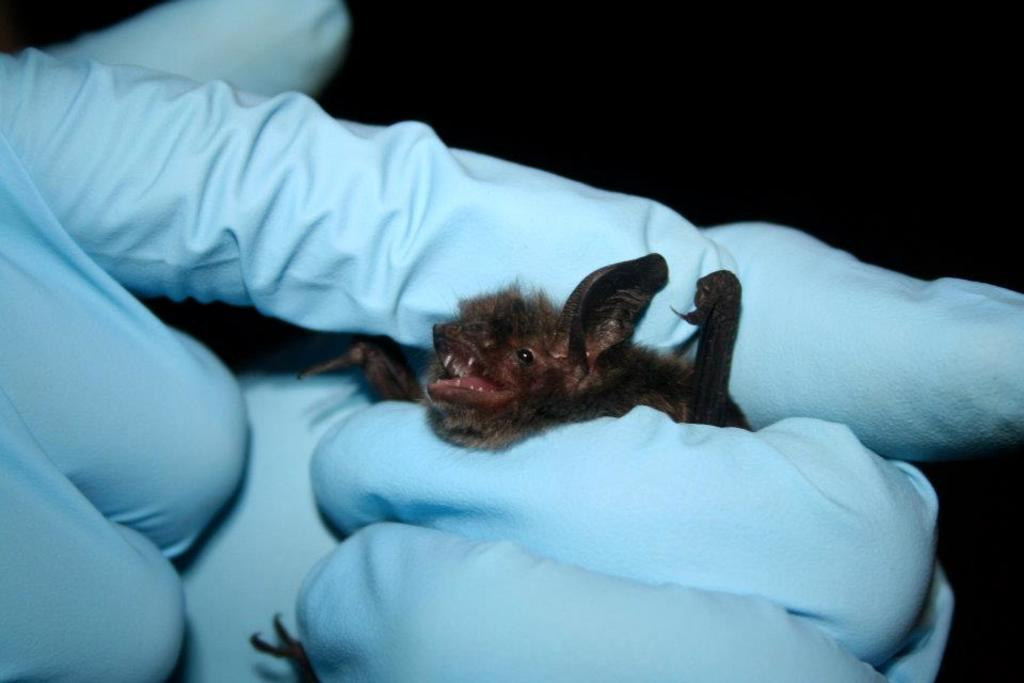What is the main subject of the image? The main subject of the image is the hands of a person wearing gloves. What is the person holding in the image? The person is holding an animal in the image. How would you describe the lighting in the image? The background of the image is very dark. What type of picture is hanging on the wall in the image? There is no mention of a picture hanging on the wall in the image, as the focus is on the hands of a person wearing gloves and the animal they are holding. 